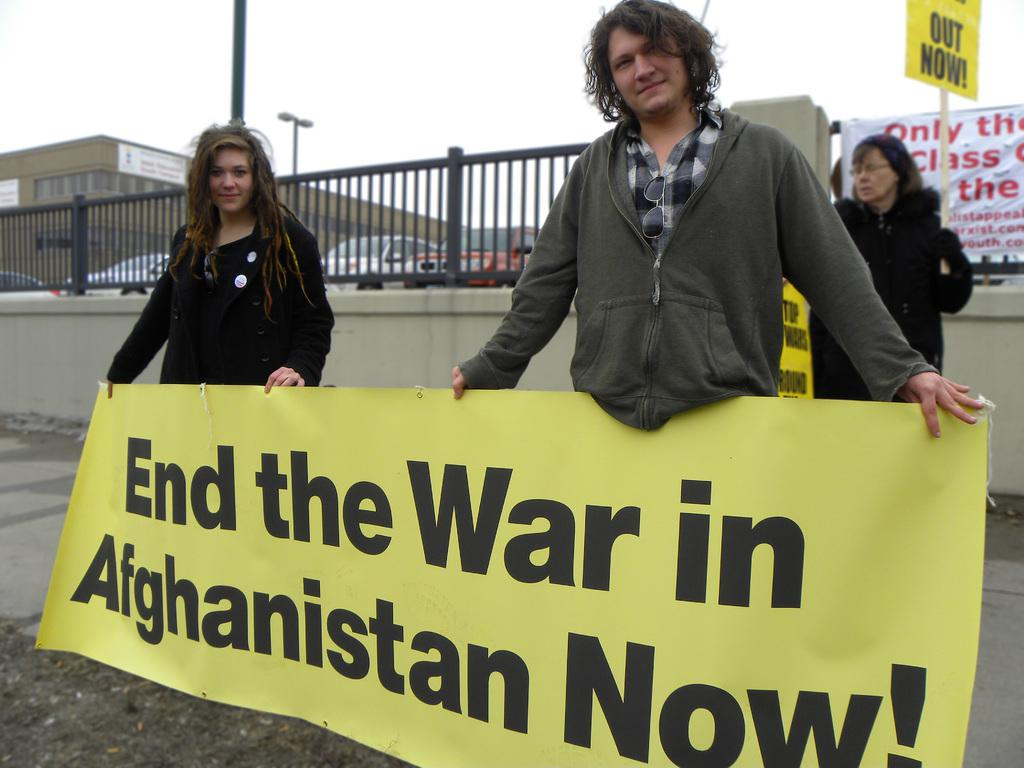What are the people in the image holding? The people in the image are holding a banner and a stick. What can be seen in the background of the image? There is a wall, a fence, vehicles, a building, and light poles in the background of the image. What is visible in the sky in the image? The sky is visible in the image. What type of circle can be seen on the banner in the image? There is no circle present on the banner in the image. Is there a turkey visible in the image? There is no turkey present in the image. 